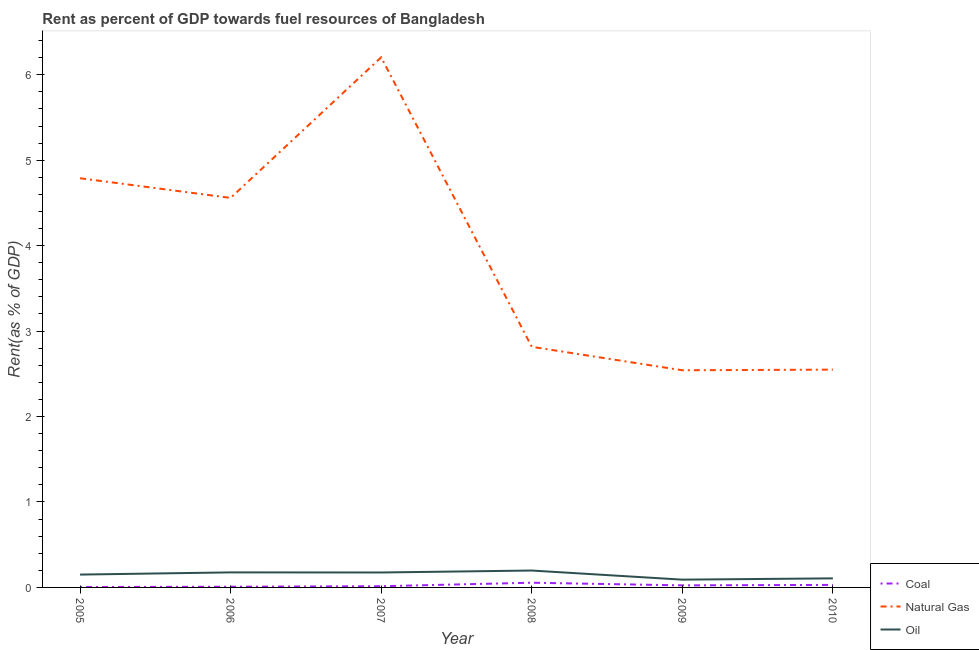Is the number of lines equal to the number of legend labels?
Your answer should be compact. Yes. What is the rent towards coal in 2008?
Offer a very short reply. 0.06. Across all years, what is the maximum rent towards coal?
Your answer should be compact. 0.06. Across all years, what is the minimum rent towards natural gas?
Offer a terse response. 2.54. In which year was the rent towards coal maximum?
Give a very brief answer. 2008. In which year was the rent towards oil minimum?
Your answer should be compact. 2009. What is the total rent towards oil in the graph?
Provide a short and direct response. 0.9. What is the difference between the rent towards natural gas in 2009 and that in 2010?
Give a very brief answer. -0.01. What is the difference between the rent towards coal in 2006 and the rent towards natural gas in 2005?
Keep it short and to the point. -4.78. What is the average rent towards oil per year?
Give a very brief answer. 0.15. In the year 2008, what is the difference between the rent towards oil and rent towards natural gas?
Your answer should be very brief. -2.62. What is the ratio of the rent towards natural gas in 2009 to that in 2010?
Your answer should be compact. 1. Is the rent towards oil in 2005 less than that in 2007?
Offer a terse response. Yes. What is the difference between the highest and the second highest rent towards oil?
Your response must be concise. 0.02. What is the difference between the highest and the lowest rent towards oil?
Give a very brief answer. 0.11. In how many years, is the rent towards oil greater than the average rent towards oil taken over all years?
Your answer should be compact. 4. Is the sum of the rent towards natural gas in 2005 and 2009 greater than the maximum rent towards oil across all years?
Offer a very short reply. Yes. Is the rent towards oil strictly greater than the rent towards coal over the years?
Provide a short and direct response. Yes. Is the rent towards coal strictly less than the rent towards oil over the years?
Offer a very short reply. Yes. How many lines are there?
Offer a very short reply. 3. What is the difference between two consecutive major ticks on the Y-axis?
Provide a succinct answer. 1. Are the values on the major ticks of Y-axis written in scientific E-notation?
Make the answer very short. No. Does the graph contain any zero values?
Ensure brevity in your answer.  No. Does the graph contain grids?
Offer a very short reply. No. What is the title of the graph?
Offer a terse response. Rent as percent of GDP towards fuel resources of Bangladesh. Does "Injury" appear as one of the legend labels in the graph?
Your response must be concise. No. What is the label or title of the Y-axis?
Give a very brief answer. Rent(as % of GDP). What is the Rent(as % of GDP) in Coal in 2005?
Offer a very short reply. 0. What is the Rent(as % of GDP) of Natural Gas in 2005?
Give a very brief answer. 4.79. What is the Rent(as % of GDP) of Oil in 2005?
Make the answer very short. 0.15. What is the Rent(as % of GDP) of Coal in 2006?
Offer a very short reply. 0.01. What is the Rent(as % of GDP) of Natural Gas in 2006?
Provide a short and direct response. 4.56. What is the Rent(as % of GDP) of Oil in 2006?
Keep it short and to the point. 0.18. What is the Rent(as % of GDP) in Coal in 2007?
Your response must be concise. 0.01. What is the Rent(as % of GDP) in Natural Gas in 2007?
Keep it short and to the point. 6.2. What is the Rent(as % of GDP) of Oil in 2007?
Offer a very short reply. 0.17. What is the Rent(as % of GDP) in Coal in 2008?
Keep it short and to the point. 0.06. What is the Rent(as % of GDP) in Natural Gas in 2008?
Keep it short and to the point. 2.82. What is the Rent(as % of GDP) of Oil in 2008?
Your answer should be compact. 0.2. What is the Rent(as % of GDP) of Coal in 2009?
Your answer should be very brief. 0.02. What is the Rent(as % of GDP) of Natural Gas in 2009?
Provide a short and direct response. 2.54. What is the Rent(as % of GDP) of Oil in 2009?
Provide a succinct answer. 0.09. What is the Rent(as % of GDP) in Coal in 2010?
Provide a succinct answer. 0.03. What is the Rent(as % of GDP) in Natural Gas in 2010?
Provide a short and direct response. 2.55. What is the Rent(as % of GDP) in Oil in 2010?
Give a very brief answer. 0.11. Across all years, what is the maximum Rent(as % of GDP) in Coal?
Offer a terse response. 0.06. Across all years, what is the maximum Rent(as % of GDP) of Natural Gas?
Provide a short and direct response. 6.2. Across all years, what is the maximum Rent(as % of GDP) of Oil?
Provide a succinct answer. 0.2. Across all years, what is the minimum Rent(as % of GDP) of Coal?
Give a very brief answer. 0. Across all years, what is the minimum Rent(as % of GDP) of Natural Gas?
Your answer should be compact. 2.54. Across all years, what is the minimum Rent(as % of GDP) of Oil?
Keep it short and to the point. 0.09. What is the total Rent(as % of GDP) of Coal in the graph?
Keep it short and to the point. 0.14. What is the total Rent(as % of GDP) in Natural Gas in the graph?
Provide a succinct answer. 23.46. What is the total Rent(as % of GDP) in Oil in the graph?
Your response must be concise. 0.9. What is the difference between the Rent(as % of GDP) in Coal in 2005 and that in 2006?
Keep it short and to the point. -0. What is the difference between the Rent(as % of GDP) in Natural Gas in 2005 and that in 2006?
Give a very brief answer. 0.23. What is the difference between the Rent(as % of GDP) in Oil in 2005 and that in 2006?
Offer a terse response. -0.03. What is the difference between the Rent(as % of GDP) in Coal in 2005 and that in 2007?
Provide a short and direct response. -0.01. What is the difference between the Rent(as % of GDP) in Natural Gas in 2005 and that in 2007?
Your answer should be very brief. -1.42. What is the difference between the Rent(as % of GDP) of Oil in 2005 and that in 2007?
Your response must be concise. -0.02. What is the difference between the Rent(as % of GDP) in Coal in 2005 and that in 2008?
Give a very brief answer. -0.05. What is the difference between the Rent(as % of GDP) in Natural Gas in 2005 and that in 2008?
Your answer should be very brief. 1.97. What is the difference between the Rent(as % of GDP) of Oil in 2005 and that in 2008?
Ensure brevity in your answer.  -0.05. What is the difference between the Rent(as % of GDP) of Coal in 2005 and that in 2009?
Offer a terse response. -0.02. What is the difference between the Rent(as % of GDP) in Natural Gas in 2005 and that in 2009?
Ensure brevity in your answer.  2.25. What is the difference between the Rent(as % of GDP) in Oil in 2005 and that in 2009?
Give a very brief answer. 0.06. What is the difference between the Rent(as % of GDP) in Coal in 2005 and that in 2010?
Provide a short and direct response. -0.03. What is the difference between the Rent(as % of GDP) in Natural Gas in 2005 and that in 2010?
Your answer should be compact. 2.24. What is the difference between the Rent(as % of GDP) in Oil in 2005 and that in 2010?
Give a very brief answer. 0.04. What is the difference between the Rent(as % of GDP) of Coal in 2006 and that in 2007?
Keep it short and to the point. -0.01. What is the difference between the Rent(as % of GDP) of Natural Gas in 2006 and that in 2007?
Offer a very short reply. -1.65. What is the difference between the Rent(as % of GDP) in Oil in 2006 and that in 2007?
Your response must be concise. 0. What is the difference between the Rent(as % of GDP) of Coal in 2006 and that in 2008?
Your answer should be very brief. -0.05. What is the difference between the Rent(as % of GDP) in Natural Gas in 2006 and that in 2008?
Provide a succinct answer. 1.74. What is the difference between the Rent(as % of GDP) in Oil in 2006 and that in 2008?
Offer a terse response. -0.02. What is the difference between the Rent(as % of GDP) of Coal in 2006 and that in 2009?
Your answer should be compact. -0.02. What is the difference between the Rent(as % of GDP) of Natural Gas in 2006 and that in 2009?
Give a very brief answer. 2.02. What is the difference between the Rent(as % of GDP) of Oil in 2006 and that in 2009?
Provide a succinct answer. 0.09. What is the difference between the Rent(as % of GDP) in Coal in 2006 and that in 2010?
Offer a terse response. -0.02. What is the difference between the Rent(as % of GDP) of Natural Gas in 2006 and that in 2010?
Offer a very short reply. 2.01. What is the difference between the Rent(as % of GDP) in Oil in 2006 and that in 2010?
Ensure brevity in your answer.  0.07. What is the difference between the Rent(as % of GDP) of Coal in 2007 and that in 2008?
Make the answer very short. -0.04. What is the difference between the Rent(as % of GDP) in Natural Gas in 2007 and that in 2008?
Ensure brevity in your answer.  3.39. What is the difference between the Rent(as % of GDP) in Oil in 2007 and that in 2008?
Offer a very short reply. -0.02. What is the difference between the Rent(as % of GDP) in Coal in 2007 and that in 2009?
Offer a terse response. -0.01. What is the difference between the Rent(as % of GDP) of Natural Gas in 2007 and that in 2009?
Provide a succinct answer. 3.66. What is the difference between the Rent(as % of GDP) in Oil in 2007 and that in 2009?
Offer a very short reply. 0.08. What is the difference between the Rent(as % of GDP) in Coal in 2007 and that in 2010?
Make the answer very short. -0.02. What is the difference between the Rent(as % of GDP) in Natural Gas in 2007 and that in 2010?
Your answer should be compact. 3.66. What is the difference between the Rent(as % of GDP) of Oil in 2007 and that in 2010?
Offer a very short reply. 0.07. What is the difference between the Rent(as % of GDP) in Coal in 2008 and that in 2009?
Ensure brevity in your answer.  0.03. What is the difference between the Rent(as % of GDP) of Natural Gas in 2008 and that in 2009?
Offer a very short reply. 0.27. What is the difference between the Rent(as % of GDP) of Oil in 2008 and that in 2009?
Provide a short and direct response. 0.11. What is the difference between the Rent(as % of GDP) of Coal in 2008 and that in 2010?
Offer a terse response. 0.03. What is the difference between the Rent(as % of GDP) of Natural Gas in 2008 and that in 2010?
Provide a short and direct response. 0.27. What is the difference between the Rent(as % of GDP) in Oil in 2008 and that in 2010?
Offer a very short reply. 0.09. What is the difference between the Rent(as % of GDP) in Coal in 2009 and that in 2010?
Your response must be concise. -0.01. What is the difference between the Rent(as % of GDP) of Natural Gas in 2009 and that in 2010?
Your response must be concise. -0.01. What is the difference between the Rent(as % of GDP) in Oil in 2009 and that in 2010?
Offer a terse response. -0.02. What is the difference between the Rent(as % of GDP) of Coal in 2005 and the Rent(as % of GDP) of Natural Gas in 2006?
Provide a short and direct response. -4.55. What is the difference between the Rent(as % of GDP) of Coal in 2005 and the Rent(as % of GDP) of Oil in 2006?
Give a very brief answer. -0.17. What is the difference between the Rent(as % of GDP) in Natural Gas in 2005 and the Rent(as % of GDP) in Oil in 2006?
Your answer should be very brief. 4.61. What is the difference between the Rent(as % of GDP) of Coal in 2005 and the Rent(as % of GDP) of Natural Gas in 2007?
Keep it short and to the point. -6.2. What is the difference between the Rent(as % of GDP) in Coal in 2005 and the Rent(as % of GDP) in Oil in 2007?
Provide a short and direct response. -0.17. What is the difference between the Rent(as % of GDP) in Natural Gas in 2005 and the Rent(as % of GDP) in Oil in 2007?
Offer a terse response. 4.61. What is the difference between the Rent(as % of GDP) in Coal in 2005 and the Rent(as % of GDP) in Natural Gas in 2008?
Provide a short and direct response. -2.81. What is the difference between the Rent(as % of GDP) in Coal in 2005 and the Rent(as % of GDP) in Oil in 2008?
Offer a terse response. -0.19. What is the difference between the Rent(as % of GDP) of Natural Gas in 2005 and the Rent(as % of GDP) of Oil in 2008?
Ensure brevity in your answer.  4.59. What is the difference between the Rent(as % of GDP) in Coal in 2005 and the Rent(as % of GDP) in Natural Gas in 2009?
Give a very brief answer. -2.54. What is the difference between the Rent(as % of GDP) in Coal in 2005 and the Rent(as % of GDP) in Oil in 2009?
Your answer should be compact. -0.09. What is the difference between the Rent(as % of GDP) in Natural Gas in 2005 and the Rent(as % of GDP) in Oil in 2009?
Provide a short and direct response. 4.7. What is the difference between the Rent(as % of GDP) of Coal in 2005 and the Rent(as % of GDP) of Natural Gas in 2010?
Your answer should be very brief. -2.54. What is the difference between the Rent(as % of GDP) of Coal in 2005 and the Rent(as % of GDP) of Oil in 2010?
Your answer should be very brief. -0.1. What is the difference between the Rent(as % of GDP) of Natural Gas in 2005 and the Rent(as % of GDP) of Oil in 2010?
Offer a terse response. 4.68. What is the difference between the Rent(as % of GDP) in Coal in 2006 and the Rent(as % of GDP) in Natural Gas in 2007?
Offer a terse response. -6.2. What is the difference between the Rent(as % of GDP) of Coal in 2006 and the Rent(as % of GDP) of Oil in 2007?
Provide a succinct answer. -0.17. What is the difference between the Rent(as % of GDP) in Natural Gas in 2006 and the Rent(as % of GDP) in Oil in 2007?
Provide a short and direct response. 4.38. What is the difference between the Rent(as % of GDP) of Coal in 2006 and the Rent(as % of GDP) of Natural Gas in 2008?
Your answer should be compact. -2.81. What is the difference between the Rent(as % of GDP) in Coal in 2006 and the Rent(as % of GDP) in Oil in 2008?
Your response must be concise. -0.19. What is the difference between the Rent(as % of GDP) of Natural Gas in 2006 and the Rent(as % of GDP) of Oil in 2008?
Your answer should be compact. 4.36. What is the difference between the Rent(as % of GDP) in Coal in 2006 and the Rent(as % of GDP) in Natural Gas in 2009?
Offer a terse response. -2.53. What is the difference between the Rent(as % of GDP) of Coal in 2006 and the Rent(as % of GDP) of Oil in 2009?
Keep it short and to the point. -0.08. What is the difference between the Rent(as % of GDP) in Natural Gas in 2006 and the Rent(as % of GDP) in Oil in 2009?
Your answer should be very brief. 4.47. What is the difference between the Rent(as % of GDP) of Coal in 2006 and the Rent(as % of GDP) of Natural Gas in 2010?
Make the answer very short. -2.54. What is the difference between the Rent(as % of GDP) of Coal in 2006 and the Rent(as % of GDP) of Oil in 2010?
Provide a short and direct response. -0.1. What is the difference between the Rent(as % of GDP) in Natural Gas in 2006 and the Rent(as % of GDP) in Oil in 2010?
Make the answer very short. 4.45. What is the difference between the Rent(as % of GDP) in Coal in 2007 and the Rent(as % of GDP) in Natural Gas in 2008?
Provide a succinct answer. -2.8. What is the difference between the Rent(as % of GDP) of Coal in 2007 and the Rent(as % of GDP) of Oil in 2008?
Your response must be concise. -0.18. What is the difference between the Rent(as % of GDP) of Natural Gas in 2007 and the Rent(as % of GDP) of Oil in 2008?
Give a very brief answer. 6.01. What is the difference between the Rent(as % of GDP) in Coal in 2007 and the Rent(as % of GDP) in Natural Gas in 2009?
Offer a terse response. -2.53. What is the difference between the Rent(as % of GDP) of Coal in 2007 and the Rent(as % of GDP) of Oil in 2009?
Your answer should be very brief. -0.08. What is the difference between the Rent(as % of GDP) in Natural Gas in 2007 and the Rent(as % of GDP) in Oil in 2009?
Make the answer very short. 6.11. What is the difference between the Rent(as % of GDP) in Coal in 2007 and the Rent(as % of GDP) in Natural Gas in 2010?
Your answer should be compact. -2.53. What is the difference between the Rent(as % of GDP) in Coal in 2007 and the Rent(as % of GDP) in Oil in 2010?
Make the answer very short. -0.09. What is the difference between the Rent(as % of GDP) in Natural Gas in 2007 and the Rent(as % of GDP) in Oil in 2010?
Your answer should be compact. 6.1. What is the difference between the Rent(as % of GDP) in Coal in 2008 and the Rent(as % of GDP) in Natural Gas in 2009?
Your answer should be very brief. -2.49. What is the difference between the Rent(as % of GDP) of Coal in 2008 and the Rent(as % of GDP) of Oil in 2009?
Keep it short and to the point. -0.04. What is the difference between the Rent(as % of GDP) of Natural Gas in 2008 and the Rent(as % of GDP) of Oil in 2009?
Keep it short and to the point. 2.72. What is the difference between the Rent(as % of GDP) in Coal in 2008 and the Rent(as % of GDP) in Natural Gas in 2010?
Give a very brief answer. -2.49. What is the difference between the Rent(as % of GDP) of Coal in 2008 and the Rent(as % of GDP) of Oil in 2010?
Ensure brevity in your answer.  -0.05. What is the difference between the Rent(as % of GDP) of Natural Gas in 2008 and the Rent(as % of GDP) of Oil in 2010?
Keep it short and to the point. 2.71. What is the difference between the Rent(as % of GDP) in Coal in 2009 and the Rent(as % of GDP) in Natural Gas in 2010?
Offer a terse response. -2.52. What is the difference between the Rent(as % of GDP) of Coal in 2009 and the Rent(as % of GDP) of Oil in 2010?
Your answer should be very brief. -0.08. What is the difference between the Rent(as % of GDP) of Natural Gas in 2009 and the Rent(as % of GDP) of Oil in 2010?
Offer a very short reply. 2.44. What is the average Rent(as % of GDP) in Coal per year?
Offer a very short reply. 0.02. What is the average Rent(as % of GDP) of Natural Gas per year?
Keep it short and to the point. 3.91. What is the average Rent(as % of GDP) in Oil per year?
Offer a terse response. 0.15. In the year 2005, what is the difference between the Rent(as % of GDP) in Coal and Rent(as % of GDP) in Natural Gas?
Offer a very short reply. -4.78. In the year 2005, what is the difference between the Rent(as % of GDP) of Coal and Rent(as % of GDP) of Oil?
Provide a short and direct response. -0.15. In the year 2005, what is the difference between the Rent(as % of GDP) of Natural Gas and Rent(as % of GDP) of Oil?
Ensure brevity in your answer.  4.64. In the year 2006, what is the difference between the Rent(as % of GDP) of Coal and Rent(as % of GDP) of Natural Gas?
Provide a succinct answer. -4.55. In the year 2006, what is the difference between the Rent(as % of GDP) of Coal and Rent(as % of GDP) of Oil?
Your response must be concise. -0.17. In the year 2006, what is the difference between the Rent(as % of GDP) in Natural Gas and Rent(as % of GDP) in Oil?
Offer a very short reply. 4.38. In the year 2007, what is the difference between the Rent(as % of GDP) of Coal and Rent(as % of GDP) of Natural Gas?
Offer a very short reply. -6.19. In the year 2007, what is the difference between the Rent(as % of GDP) in Coal and Rent(as % of GDP) in Oil?
Provide a short and direct response. -0.16. In the year 2007, what is the difference between the Rent(as % of GDP) of Natural Gas and Rent(as % of GDP) of Oil?
Your answer should be compact. 6.03. In the year 2008, what is the difference between the Rent(as % of GDP) of Coal and Rent(as % of GDP) of Natural Gas?
Your answer should be compact. -2.76. In the year 2008, what is the difference between the Rent(as % of GDP) of Coal and Rent(as % of GDP) of Oil?
Offer a very short reply. -0.14. In the year 2008, what is the difference between the Rent(as % of GDP) of Natural Gas and Rent(as % of GDP) of Oil?
Your answer should be very brief. 2.62. In the year 2009, what is the difference between the Rent(as % of GDP) of Coal and Rent(as % of GDP) of Natural Gas?
Your response must be concise. -2.52. In the year 2009, what is the difference between the Rent(as % of GDP) in Coal and Rent(as % of GDP) in Oil?
Your response must be concise. -0.07. In the year 2009, what is the difference between the Rent(as % of GDP) in Natural Gas and Rent(as % of GDP) in Oil?
Keep it short and to the point. 2.45. In the year 2010, what is the difference between the Rent(as % of GDP) of Coal and Rent(as % of GDP) of Natural Gas?
Keep it short and to the point. -2.52. In the year 2010, what is the difference between the Rent(as % of GDP) in Coal and Rent(as % of GDP) in Oil?
Make the answer very short. -0.08. In the year 2010, what is the difference between the Rent(as % of GDP) in Natural Gas and Rent(as % of GDP) in Oil?
Provide a succinct answer. 2.44. What is the ratio of the Rent(as % of GDP) in Coal in 2005 to that in 2006?
Your response must be concise. 0.55. What is the ratio of the Rent(as % of GDP) of Natural Gas in 2005 to that in 2006?
Offer a very short reply. 1.05. What is the ratio of the Rent(as % of GDP) in Oil in 2005 to that in 2006?
Make the answer very short. 0.85. What is the ratio of the Rent(as % of GDP) of Coal in 2005 to that in 2007?
Provide a short and direct response. 0.32. What is the ratio of the Rent(as % of GDP) in Natural Gas in 2005 to that in 2007?
Your answer should be very brief. 0.77. What is the ratio of the Rent(as % of GDP) of Oil in 2005 to that in 2007?
Make the answer very short. 0.86. What is the ratio of the Rent(as % of GDP) in Coal in 2005 to that in 2008?
Provide a short and direct response. 0.08. What is the ratio of the Rent(as % of GDP) of Natural Gas in 2005 to that in 2008?
Give a very brief answer. 1.7. What is the ratio of the Rent(as % of GDP) in Oil in 2005 to that in 2008?
Make the answer very short. 0.76. What is the ratio of the Rent(as % of GDP) in Coal in 2005 to that in 2009?
Your answer should be compact. 0.19. What is the ratio of the Rent(as % of GDP) in Natural Gas in 2005 to that in 2009?
Ensure brevity in your answer.  1.88. What is the ratio of the Rent(as % of GDP) in Oil in 2005 to that in 2009?
Your response must be concise. 1.65. What is the ratio of the Rent(as % of GDP) in Coal in 2005 to that in 2010?
Keep it short and to the point. 0.15. What is the ratio of the Rent(as % of GDP) in Natural Gas in 2005 to that in 2010?
Offer a terse response. 1.88. What is the ratio of the Rent(as % of GDP) in Oil in 2005 to that in 2010?
Provide a short and direct response. 1.42. What is the ratio of the Rent(as % of GDP) of Coal in 2006 to that in 2007?
Your response must be concise. 0.58. What is the ratio of the Rent(as % of GDP) of Natural Gas in 2006 to that in 2007?
Keep it short and to the point. 0.73. What is the ratio of the Rent(as % of GDP) in Coal in 2006 to that in 2008?
Provide a succinct answer. 0.15. What is the ratio of the Rent(as % of GDP) of Natural Gas in 2006 to that in 2008?
Your answer should be compact. 1.62. What is the ratio of the Rent(as % of GDP) of Oil in 2006 to that in 2008?
Offer a very short reply. 0.89. What is the ratio of the Rent(as % of GDP) in Coal in 2006 to that in 2009?
Ensure brevity in your answer.  0.34. What is the ratio of the Rent(as % of GDP) in Natural Gas in 2006 to that in 2009?
Provide a short and direct response. 1.79. What is the ratio of the Rent(as % of GDP) of Oil in 2006 to that in 2009?
Ensure brevity in your answer.  1.93. What is the ratio of the Rent(as % of GDP) of Coal in 2006 to that in 2010?
Provide a short and direct response. 0.28. What is the ratio of the Rent(as % of GDP) of Natural Gas in 2006 to that in 2010?
Keep it short and to the point. 1.79. What is the ratio of the Rent(as % of GDP) in Oil in 2006 to that in 2010?
Offer a terse response. 1.66. What is the ratio of the Rent(as % of GDP) in Coal in 2007 to that in 2008?
Make the answer very short. 0.26. What is the ratio of the Rent(as % of GDP) in Natural Gas in 2007 to that in 2008?
Provide a succinct answer. 2.2. What is the ratio of the Rent(as % of GDP) of Oil in 2007 to that in 2008?
Ensure brevity in your answer.  0.88. What is the ratio of the Rent(as % of GDP) in Coal in 2007 to that in 2009?
Make the answer very short. 0.59. What is the ratio of the Rent(as % of GDP) of Natural Gas in 2007 to that in 2009?
Your response must be concise. 2.44. What is the ratio of the Rent(as % of GDP) in Oil in 2007 to that in 2009?
Make the answer very short. 1.92. What is the ratio of the Rent(as % of GDP) of Coal in 2007 to that in 2010?
Give a very brief answer. 0.48. What is the ratio of the Rent(as % of GDP) of Natural Gas in 2007 to that in 2010?
Your answer should be compact. 2.43. What is the ratio of the Rent(as % of GDP) of Oil in 2007 to that in 2010?
Provide a short and direct response. 1.65. What is the ratio of the Rent(as % of GDP) of Coal in 2008 to that in 2009?
Your response must be concise. 2.3. What is the ratio of the Rent(as % of GDP) of Natural Gas in 2008 to that in 2009?
Give a very brief answer. 1.11. What is the ratio of the Rent(as % of GDP) of Oil in 2008 to that in 2009?
Make the answer very short. 2.17. What is the ratio of the Rent(as % of GDP) of Coal in 2008 to that in 2010?
Provide a succinct answer. 1.86. What is the ratio of the Rent(as % of GDP) of Natural Gas in 2008 to that in 2010?
Provide a succinct answer. 1.1. What is the ratio of the Rent(as % of GDP) in Oil in 2008 to that in 2010?
Your answer should be compact. 1.86. What is the ratio of the Rent(as % of GDP) in Coal in 2009 to that in 2010?
Provide a succinct answer. 0.81. What is the ratio of the Rent(as % of GDP) in Natural Gas in 2009 to that in 2010?
Provide a short and direct response. 1. What is the ratio of the Rent(as % of GDP) in Oil in 2009 to that in 2010?
Give a very brief answer. 0.86. What is the difference between the highest and the second highest Rent(as % of GDP) of Coal?
Give a very brief answer. 0.03. What is the difference between the highest and the second highest Rent(as % of GDP) of Natural Gas?
Give a very brief answer. 1.42. What is the difference between the highest and the second highest Rent(as % of GDP) of Oil?
Offer a terse response. 0.02. What is the difference between the highest and the lowest Rent(as % of GDP) of Coal?
Make the answer very short. 0.05. What is the difference between the highest and the lowest Rent(as % of GDP) of Natural Gas?
Make the answer very short. 3.66. What is the difference between the highest and the lowest Rent(as % of GDP) of Oil?
Ensure brevity in your answer.  0.11. 